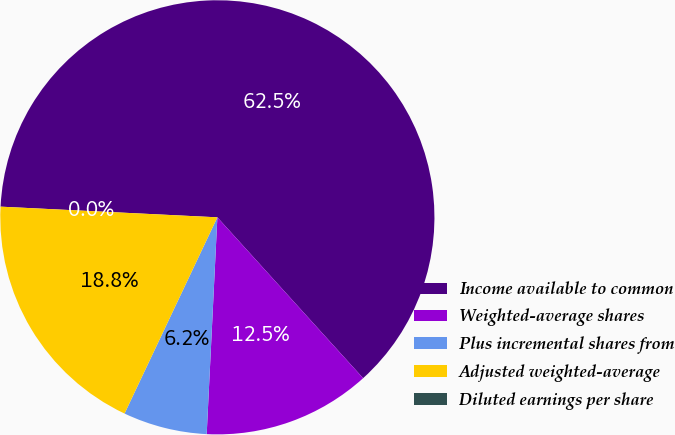<chart> <loc_0><loc_0><loc_500><loc_500><pie_chart><fcel>Income available to common<fcel>Weighted-average shares<fcel>Plus incremental shares from<fcel>Adjusted weighted-average<fcel>Diluted earnings per share<nl><fcel>62.5%<fcel>12.5%<fcel>6.25%<fcel>18.75%<fcel>0.0%<nl></chart> 